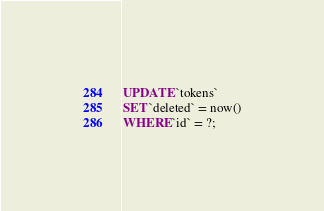Convert code to text. <code><loc_0><loc_0><loc_500><loc_500><_SQL_>UPDATE `tokens`
SET `deleted` = now()
WHERE `id` = ?;</code> 